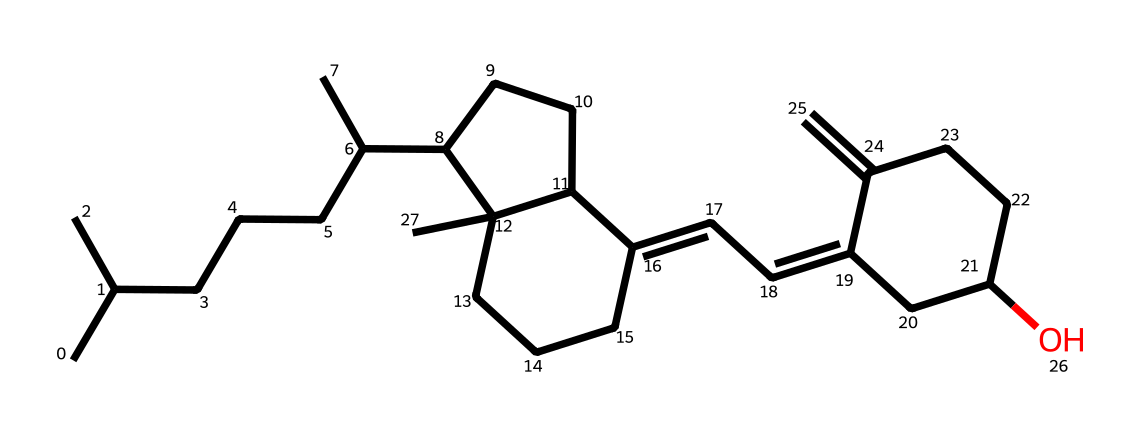What is the molecular formula of vitamin D based on the SMILES representation? To find the molecular formula, we identify the elements in the SMILES and count the atoms. The structure indicates a presence of carbon (C), hydrogen (H), and possibly oxygen (O). The count reveals 27 carbons, 46 hydrogens, and 1 oxygen. Thus, we can write the molecular formula as C27H46O.
Answer: C27H46O How many rings are present in the chemical structure of vitamin D? Examining the SMILES, we can identify the closed loops or rings indicated by the numbering of carbon atoms. There are two distinct ring structures in the representation, which we can confirm by following the numerical indicators in the SMILES.
Answer: 2 What functional group is indicated by the 'O' in the SMILES for vitamin D? In the SMILES, the 'O' at the end signifies the presence of a hydroxyl (-OH) functional group, which is critical for the chemical properties of vitamin D. The hydroxyl group contributes to the solubility and reactivity of the molecule.
Answer: hydroxyl What is the primary role of vitamin D in the body? Vitamin D is primarily known for its role in calcium absorption, which is crucial for maintaining bone health. This function aids in preventing bone-related disorders such as rickets in children and osteomalacia in adults.
Answer: calcium absorption How does the structure of vitamin D relate to its function in bone health? The structure of vitamin D allows it to bind to vitamin D receptors in the intestines and kidneys, enhancing the transfer and reabsorption of calcium. The presence of a hydroxyl group also enhances this function, linking structural features with physiological roles.
Answer: binding to receptors Which part of vitamin D is primarily responsible for its biological activity? The active form of vitamin D, calcitriol, is influenced by the functional groups present, particularly the hydroxyl group which enhances its interaction with target tissues and receptors critical for its biological activity.
Answer: hydroxyl group 